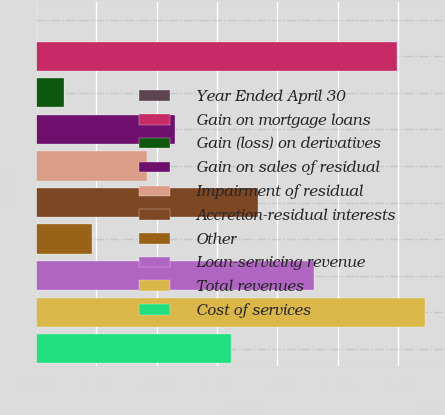Convert chart to OTSL. <chart><loc_0><loc_0><loc_500><loc_500><bar_chart><fcel>Year Ended April 30<fcel>Gain on mortgage loans<fcel>Gain (loss) on derivatives<fcel>Gain on sales of residual<fcel>Impairment of residual<fcel>Accretion-residual interests<fcel>Other<fcel>Loan-servicing revenue<fcel>Total revenues<fcel>Cost of services<nl><fcel>2003<fcel>1.4945e+06<fcel>116811<fcel>576042<fcel>461234<fcel>920465<fcel>231618<fcel>1.15008e+06<fcel>1.60931e+06<fcel>805657<nl></chart> 